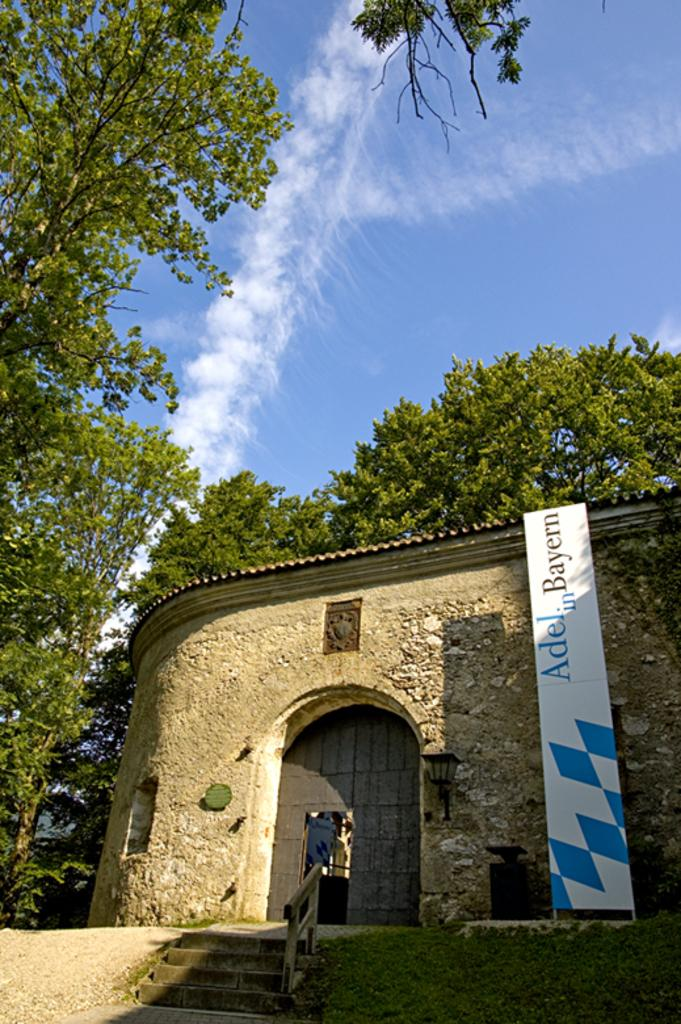What type of structure is visible in the image? There is a house in the image. What part of the house allows entry? There is a door in the image. Are there any architectural features that provide access to the house? Yes, there are steps in the image. What type of advertisement or announcement is present in the image? There is a hoarding in the image. Is there any source of illumination visible in the image? Yes, there is a light on the wall in the image. What type of natural elements can be seen in the image? There are trees and clouds in the image. How does the visitor respond to the attack in the image? There is no mention of a visitor or an attack in the image; it only features a house, door, steps, hoarding, light, trees, and clouds. 